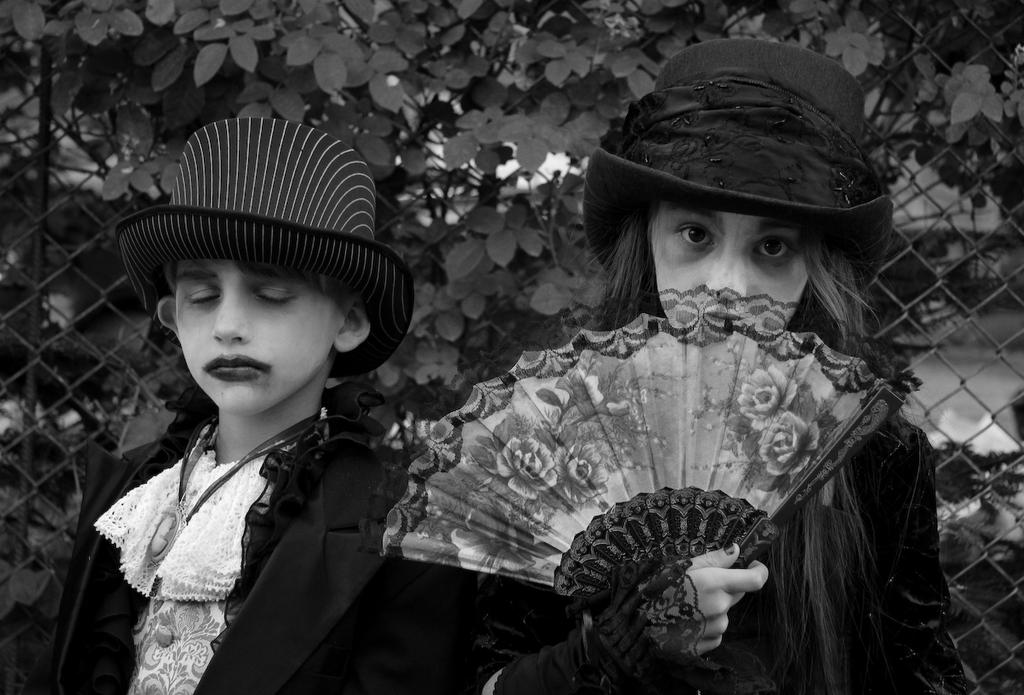How many people are in the image? There are two persons in the image. What is one person doing in the image? One person is holding a hand fan. What can be seen behind the persons in the image? There is a fencing and plants visible behind the persons. What type of shoe is the minister wearing in the image? There is no minister or shoe present in the image. How many porters are visible in the image? There are no porters present in the image. 